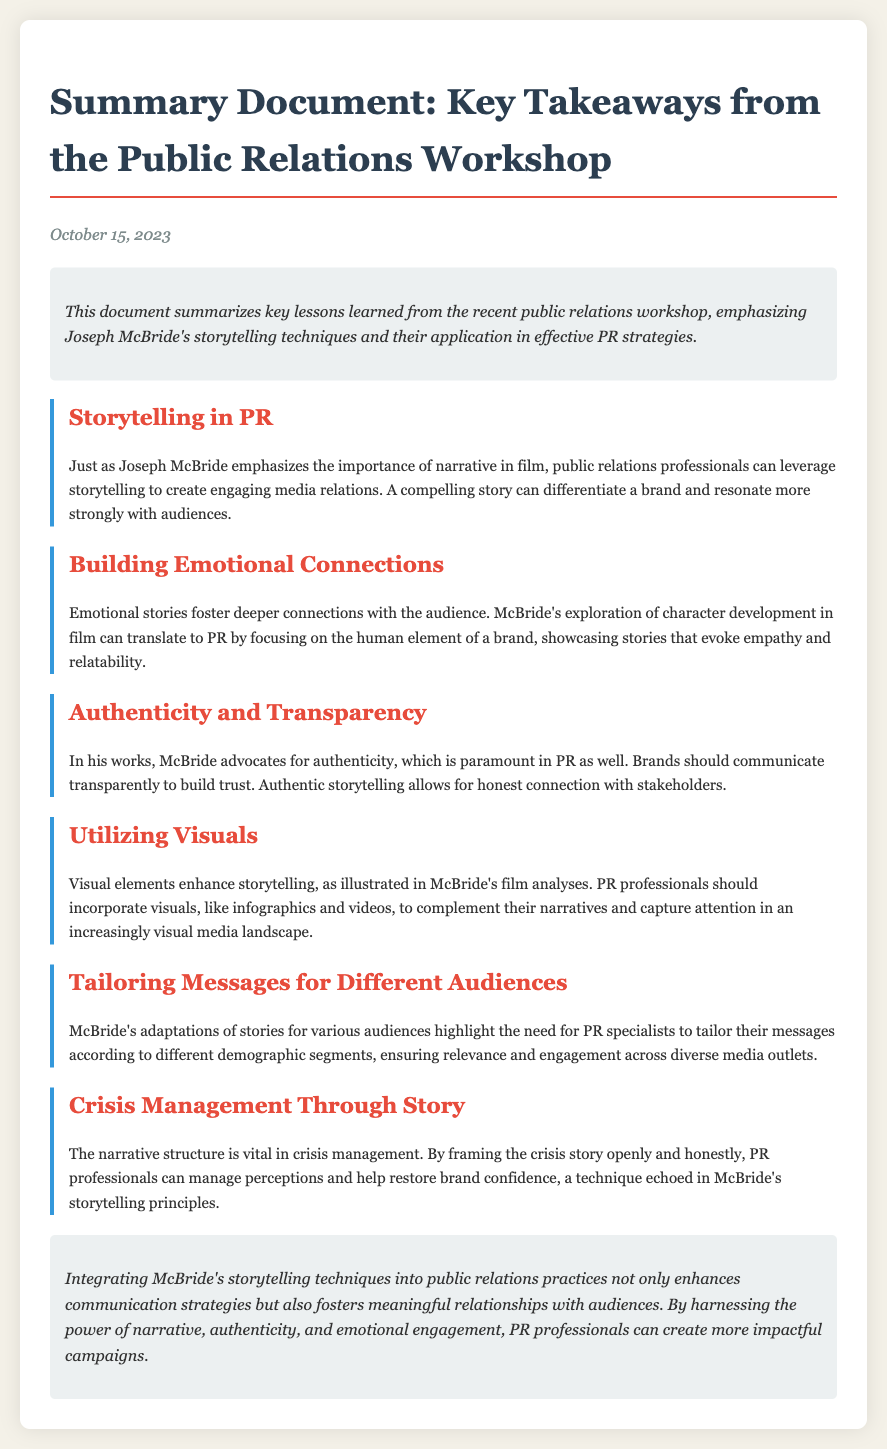What date was the workshop summary document published? The date listed in the document is October 15, 2023.
Answer: October 15, 2023 Who is the author referenced for storytelling techniques? The document emphasizes storytelling techniques by Joseph McBride.
Answer: Joseph McBride What emotional aspect should PR professionals focus on according to the document? The document suggests that emotional stories foster deeper connections with the audience.
Answer: Emotional connections Which storytelling principle is emphasized for crisis management? The document highlights the importance of framing the crisis story openly and honestly.
Answer: Narrative structure What visual elements are recommended for enhancing storytelling in PR? The document advises incorporating visuals like infographics and videos.
Answer: Visuals How many key takeaways are discussed in the document? The document highlights six key takeaways from the workshop.
Answer: Six What theme is reiterated regarding brand communication? The document discusses the theme of authenticity and transparency in brand communication.
Answer: Authenticity and transparency Which takeaway discusses the importance of tailoring messages? The document states that tailoring messages for different audiences is crucial.
Answer: Tailoring messages What technique is suggested to differentiate a brand? The document mentions that storytelling can differentiate a brand and resonate with audiences.
Answer: Storytelling 